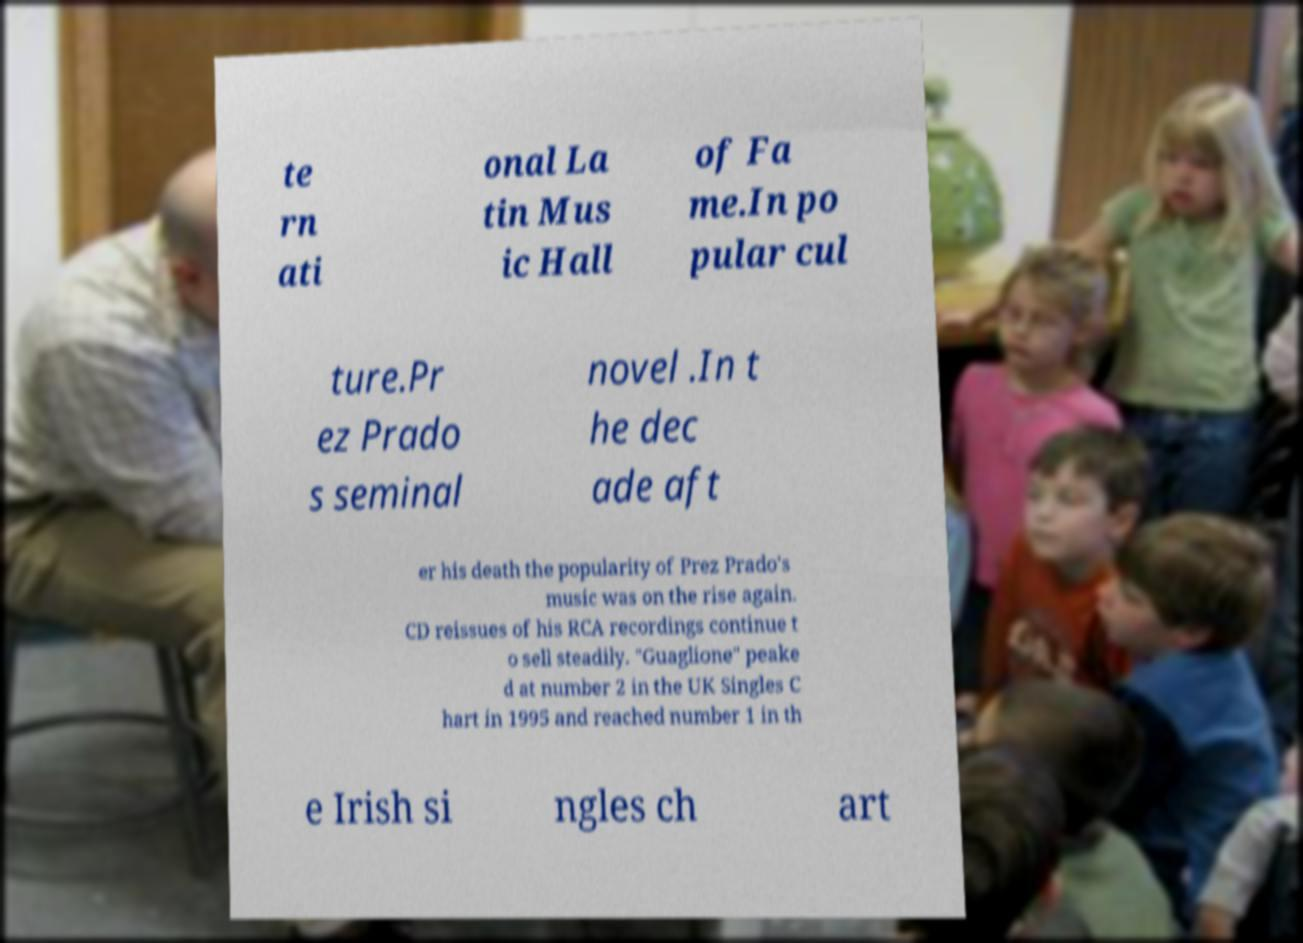Please identify and transcribe the text found in this image. te rn ati onal La tin Mus ic Hall of Fa me.In po pular cul ture.Pr ez Prado s seminal novel .In t he dec ade aft er his death the popularity of Prez Prado's music was on the rise again. CD reissues of his RCA recordings continue t o sell steadily. "Guaglione" peake d at number 2 in the UK Singles C hart in 1995 and reached number 1 in th e Irish si ngles ch art 